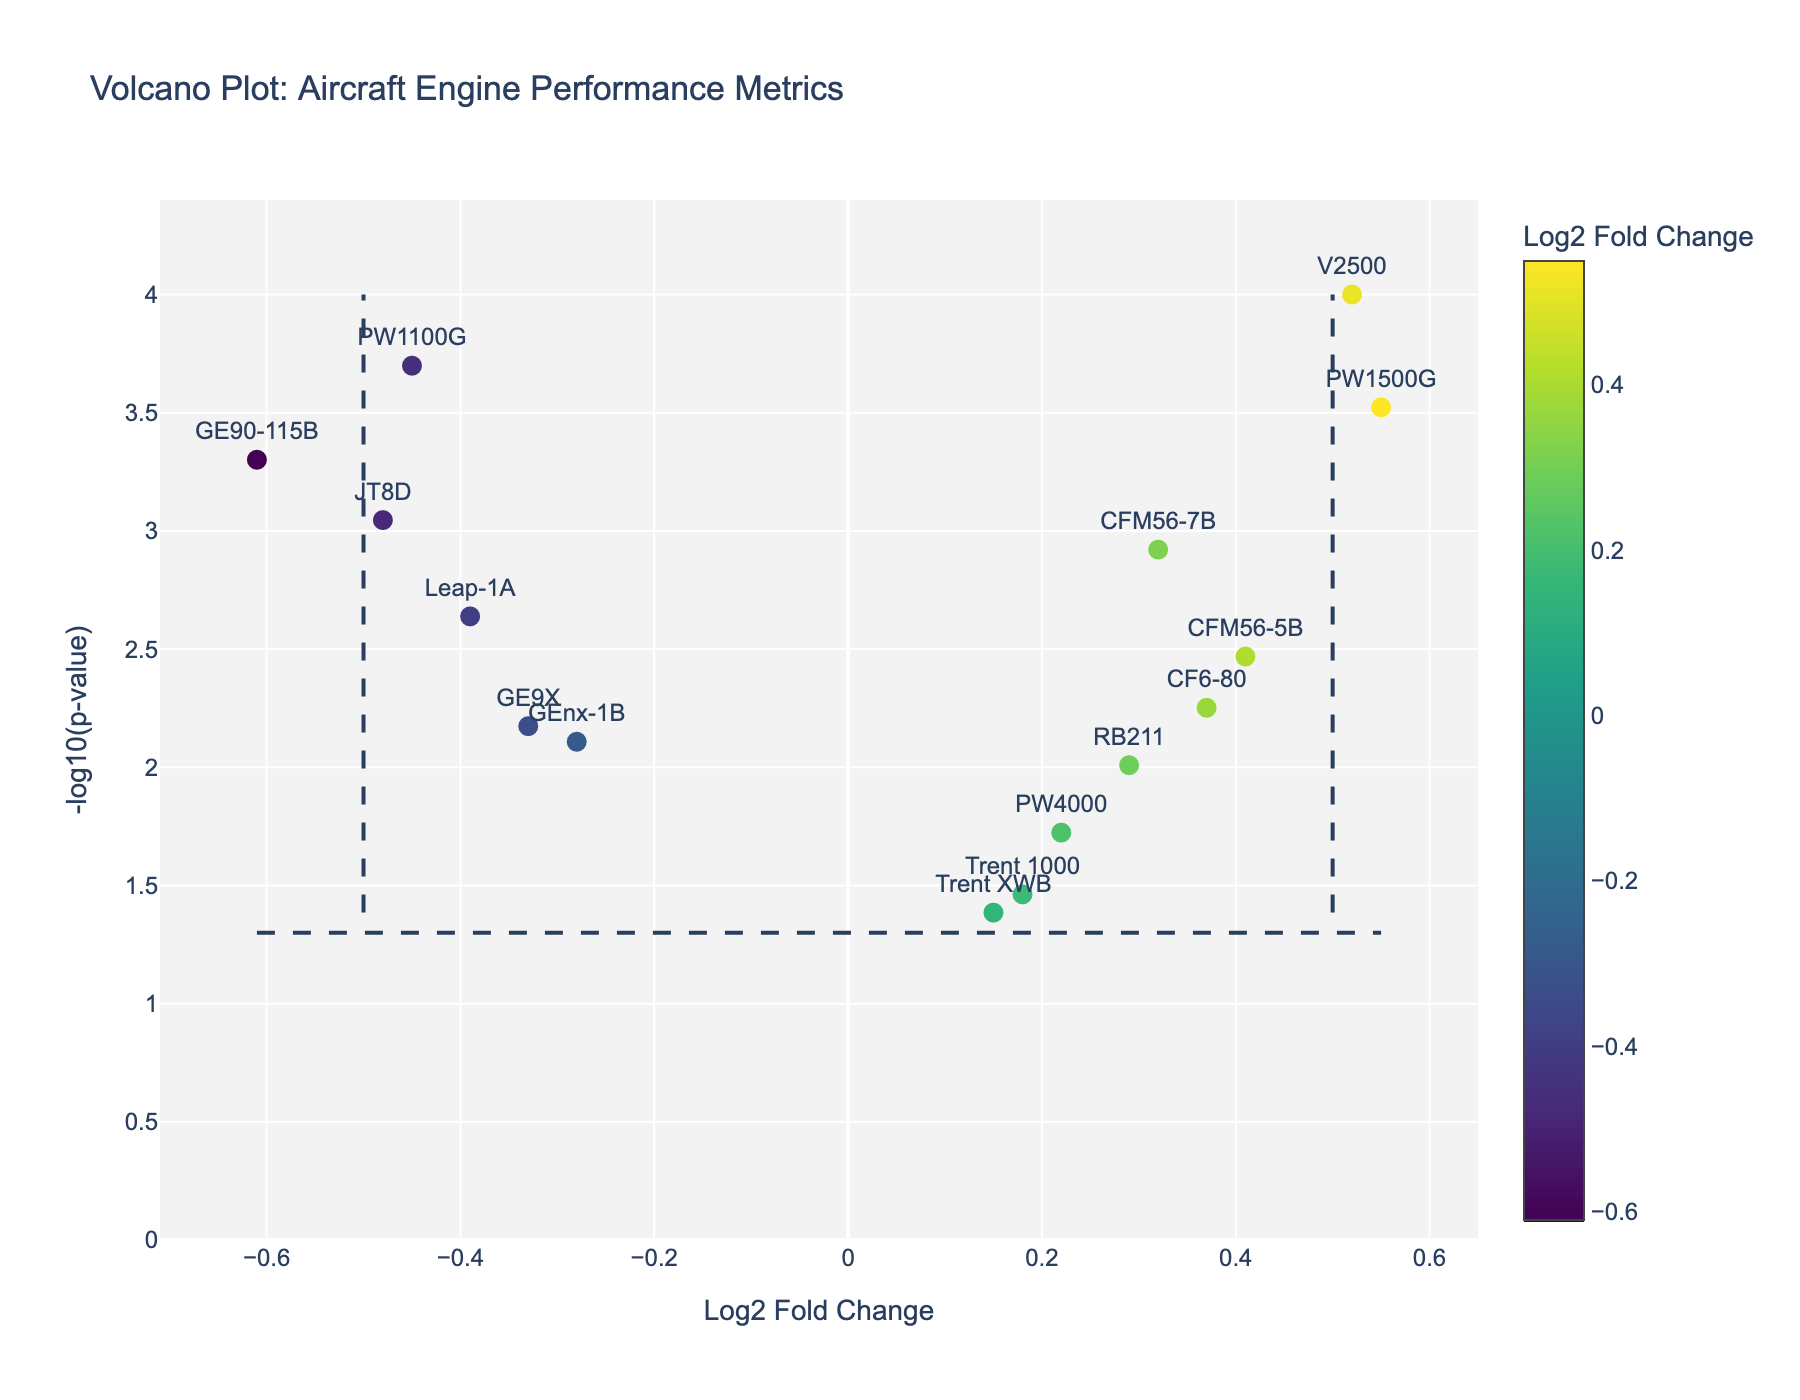How many engine types are depicted in the figure? To find the number of engine types, visually count the unique data points (markers) on the plot. Each marker represents a different engine type as indicated by the labels next to them.
Answer: 15 What does the vertical dashed line at 0.5 signify? The vertical dashed line at a log2 fold change of 0.5 typically marks a threshold level above which changes in performance metrics are considered significantly improved.
Answer: Threshold for significant improvement Which engine type has the highest log2 fold change, and what is its corresponding metric? Locate the marker with the highest log2 fold change along the x-axis, then observe the text label next to it to identify the engine type and corresponding metric.
Answer: PW1500G, Maintenance Intervals What is indicated by markers above the horizontal dashed line at -log10(p-value) ≈ 1.3? Markers above the horizontal dashed line at -log10(p-value) ≈ 1.3 represent data points with p-values less than 0.05, indicating statistical significance in the performance metric changes.
Answer: Statistically significant changes Which engine type has the lowest log2 fold change and what is its corresponding performance metric? Find the marker with the lowest log2 fold change along the x-axis and check the text label adjacent to it to identify the engine type and performance metric.
Answer: GE90-115B, Oil Consumption Compare the log2 fold changes for CFM56-5B and Trent XWB engines. Which one has the higher fold change and by how much? Identify the log2 fold changes for CFM56-5B (0.41) and Trent XWB (0.15) by locating their markers and reading the values. Calculate the difference: 0.41 - 0.15.
Answer: CFM56-5B, by 0.26 Which engine and metric have the smallest p-value, and why is this significant? Find the marker with the highest -log10(p-value), indicating the smallest p-value. Check the text label to determine the engine and metric. A smaller p-value means a higher significance of the observed change.
Answer: V2500, EGT Margin Which engine types show a negative log2 fold change in performance after maintenance, and what are their metrics? Look for markers on the left side of the x-axis (negative log2 fold change). Identify the text labels for these markers to find the corresponding engines and metrics.
Answer: PW1100G (NOx Emissions), Leap-1A (Fan Blade Vibration), GE90-115B (Oil Consumption), JT8D (Exhaust Gas Temperature), GE9X (Fuel Flow Rate) What does the color scale represent in the plot? The color scale on the right side of the plot indicates the range of log2 fold change values, with different colors representing different magnitudes of change.
Answer: Log2 fold change Considering engines with significant p-values (above the horizontal dashed line), which of them show improved performance after maintenance? Identify markers above the horizontal dashed line with positive log2 fold changes, indicating significant and positive performance improvements. Check their text labels.
Answer: CFM56-7B, V2500, PW1500G, CFM56-5B, RB211 